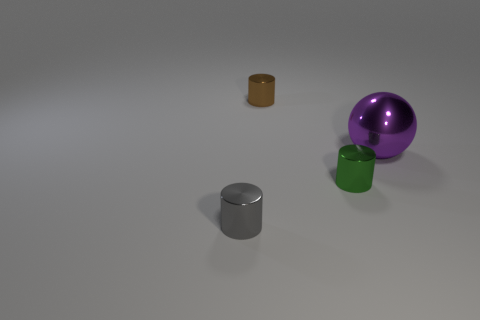Subtract all green cylinders. How many cylinders are left? 2 Subtract 1 cylinders. How many cylinders are left? 2 Subtract all cylinders. How many objects are left? 1 Subtract all yellow cylinders. Subtract all green balls. How many cylinders are left? 3 Add 2 large green metal spheres. How many objects exist? 6 Subtract all balls. Subtract all tiny brown metallic cylinders. How many objects are left? 2 Add 3 large shiny spheres. How many large shiny spheres are left? 4 Add 4 big purple things. How many big purple things exist? 5 Subtract 0 cyan spheres. How many objects are left? 4 